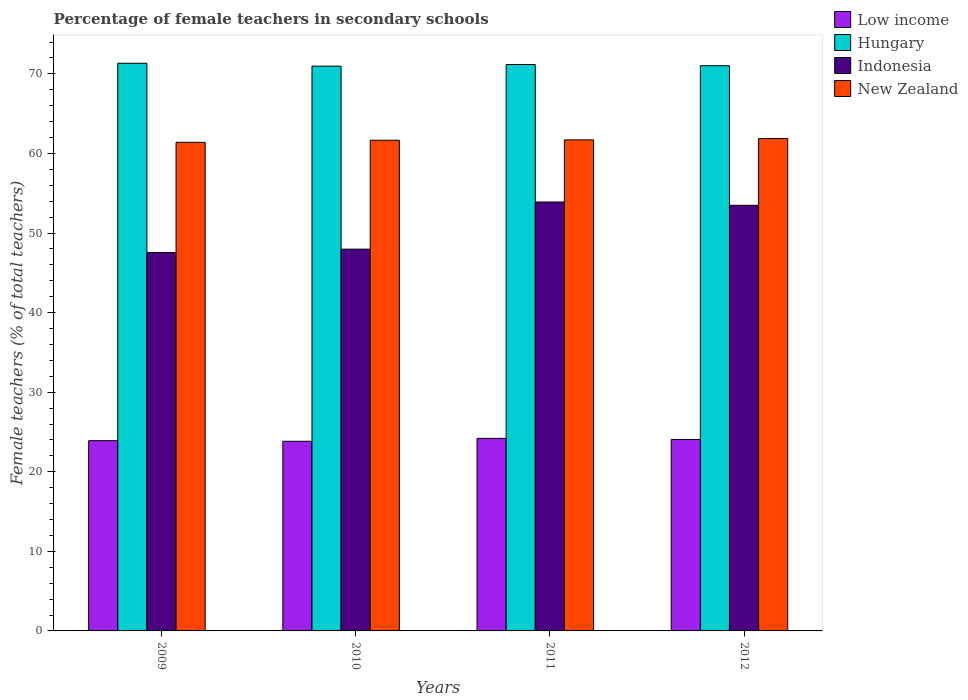How many different coloured bars are there?
Offer a very short reply. 4. Are the number of bars per tick equal to the number of legend labels?
Offer a terse response. Yes. What is the label of the 3rd group of bars from the left?
Keep it short and to the point. 2011. In how many cases, is the number of bars for a given year not equal to the number of legend labels?
Make the answer very short. 0. What is the percentage of female teachers in Indonesia in 2009?
Offer a terse response. 47.56. Across all years, what is the maximum percentage of female teachers in Low income?
Provide a succinct answer. 24.19. Across all years, what is the minimum percentage of female teachers in Indonesia?
Offer a terse response. 47.56. In which year was the percentage of female teachers in Low income minimum?
Make the answer very short. 2010. What is the total percentage of female teachers in Low income in the graph?
Provide a short and direct response. 95.99. What is the difference between the percentage of female teachers in New Zealand in 2009 and that in 2011?
Provide a short and direct response. -0.31. What is the difference between the percentage of female teachers in Hungary in 2010 and the percentage of female teachers in Indonesia in 2009?
Offer a very short reply. 23.41. What is the average percentage of female teachers in Indonesia per year?
Offer a terse response. 50.73. In the year 2011, what is the difference between the percentage of female teachers in Indonesia and percentage of female teachers in Low income?
Provide a succinct answer. 29.7. In how many years, is the percentage of female teachers in New Zealand greater than 28 %?
Your response must be concise. 4. What is the ratio of the percentage of female teachers in Hungary in 2009 to that in 2010?
Offer a very short reply. 1.01. Is the percentage of female teachers in Hungary in 2010 less than that in 2012?
Offer a terse response. Yes. Is the difference between the percentage of female teachers in Indonesia in 2009 and 2012 greater than the difference between the percentage of female teachers in Low income in 2009 and 2012?
Provide a short and direct response. No. What is the difference between the highest and the second highest percentage of female teachers in New Zealand?
Ensure brevity in your answer.  0.17. What is the difference between the highest and the lowest percentage of female teachers in Low income?
Your answer should be compact. 0.36. In how many years, is the percentage of female teachers in Low income greater than the average percentage of female teachers in Low income taken over all years?
Offer a terse response. 2. Is the sum of the percentage of female teachers in Hungary in 2009 and 2012 greater than the maximum percentage of female teachers in Low income across all years?
Offer a very short reply. Yes. Is it the case that in every year, the sum of the percentage of female teachers in New Zealand and percentage of female teachers in Indonesia is greater than the sum of percentage of female teachers in Low income and percentage of female teachers in Hungary?
Keep it short and to the point. Yes. What does the 1st bar from the left in 2012 represents?
Ensure brevity in your answer.  Low income. Is it the case that in every year, the sum of the percentage of female teachers in Hungary and percentage of female teachers in Low income is greater than the percentage of female teachers in Indonesia?
Make the answer very short. Yes. How many bars are there?
Offer a terse response. 16. How many years are there in the graph?
Offer a terse response. 4. Are the values on the major ticks of Y-axis written in scientific E-notation?
Provide a succinct answer. No. Does the graph contain grids?
Your answer should be very brief. No. Where does the legend appear in the graph?
Provide a short and direct response. Top right. What is the title of the graph?
Your answer should be very brief. Percentage of female teachers in secondary schools. Does "Equatorial Guinea" appear as one of the legend labels in the graph?
Provide a short and direct response. No. What is the label or title of the X-axis?
Keep it short and to the point. Years. What is the label or title of the Y-axis?
Make the answer very short. Female teachers (% of total teachers). What is the Female teachers (% of total teachers) in Low income in 2009?
Your answer should be very brief. 23.91. What is the Female teachers (% of total teachers) in Hungary in 2009?
Provide a succinct answer. 71.33. What is the Female teachers (% of total teachers) of Indonesia in 2009?
Provide a short and direct response. 47.56. What is the Female teachers (% of total teachers) in New Zealand in 2009?
Your answer should be compact. 61.4. What is the Female teachers (% of total teachers) of Low income in 2010?
Ensure brevity in your answer.  23.83. What is the Female teachers (% of total teachers) of Hungary in 2010?
Your response must be concise. 70.97. What is the Female teachers (% of total teachers) in Indonesia in 2010?
Offer a terse response. 47.97. What is the Female teachers (% of total teachers) in New Zealand in 2010?
Ensure brevity in your answer.  61.66. What is the Female teachers (% of total teachers) in Low income in 2011?
Your answer should be very brief. 24.19. What is the Female teachers (% of total teachers) in Hungary in 2011?
Offer a very short reply. 71.18. What is the Female teachers (% of total teachers) in Indonesia in 2011?
Your response must be concise. 53.9. What is the Female teachers (% of total teachers) in New Zealand in 2011?
Your answer should be compact. 61.71. What is the Female teachers (% of total teachers) in Low income in 2012?
Make the answer very short. 24.06. What is the Female teachers (% of total teachers) in Hungary in 2012?
Make the answer very short. 71.02. What is the Female teachers (% of total teachers) in Indonesia in 2012?
Your answer should be compact. 53.48. What is the Female teachers (% of total teachers) of New Zealand in 2012?
Your answer should be very brief. 61.88. Across all years, what is the maximum Female teachers (% of total teachers) of Low income?
Offer a very short reply. 24.19. Across all years, what is the maximum Female teachers (% of total teachers) of Hungary?
Keep it short and to the point. 71.33. Across all years, what is the maximum Female teachers (% of total teachers) in Indonesia?
Your response must be concise. 53.9. Across all years, what is the maximum Female teachers (% of total teachers) in New Zealand?
Keep it short and to the point. 61.88. Across all years, what is the minimum Female teachers (% of total teachers) in Low income?
Offer a terse response. 23.83. Across all years, what is the minimum Female teachers (% of total teachers) of Hungary?
Ensure brevity in your answer.  70.97. Across all years, what is the minimum Female teachers (% of total teachers) in Indonesia?
Offer a terse response. 47.56. Across all years, what is the minimum Female teachers (% of total teachers) of New Zealand?
Your answer should be compact. 61.4. What is the total Female teachers (% of total teachers) of Low income in the graph?
Offer a very short reply. 95.99. What is the total Female teachers (% of total teachers) in Hungary in the graph?
Provide a succinct answer. 284.5. What is the total Female teachers (% of total teachers) of Indonesia in the graph?
Your answer should be compact. 202.91. What is the total Female teachers (% of total teachers) of New Zealand in the graph?
Provide a succinct answer. 246.64. What is the difference between the Female teachers (% of total teachers) of Low income in 2009 and that in 2010?
Your answer should be compact. 0.08. What is the difference between the Female teachers (% of total teachers) in Hungary in 2009 and that in 2010?
Provide a succinct answer. 0.36. What is the difference between the Female teachers (% of total teachers) in Indonesia in 2009 and that in 2010?
Offer a terse response. -0.41. What is the difference between the Female teachers (% of total teachers) of New Zealand in 2009 and that in 2010?
Give a very brief answer. -0.26. What is the difference between the Female teachers (% of total teachers) of Low income in 2009 and that in 2011?
Make the answer very short. -0.29. What is the difference between the Female teachers (% of total teachers) of Hungary in 2009 and that in 2011?
Your answer should be compact. 0.15. What is the difference between the Female teachers (% of total teachers) of Indonesia in 2009 and that in 2011?
Ensure brevity in your answer.  -6.34. What is the difference between the Female teachers (% of total teachers) of New Zealand in 2009 and that in 2011?
Make the answer very short. -0.31. What is the difference between the Female teachers (% of total teachers) of Low income in 2009 and that in 2012?
Ensure brevity in your answer.  -0.16. What is the difference between the Female teachers (% of total teachers) in Hungary in 2009 and that in 2012?
Offer a terse response. 0.31. What is the difference between the Female teachers (% of total teachers) of Indonesia in 2009 and that in 2012?
Offer a terse response. -5.92. What is the difference between the Female teachers (% of total teachers) in New Zealand in 2009 and that in 2012?
Your answer should be compact. -0.48. What is the difference between the Female teachers (% of total teachers) in Low income in 2010 and that in 2011?
Offer a terse response. -0.36. What is the difference between the Female teachers (% of total teachers) in Hungary in 2010 and that in 2011?
Your answer should be compact. -0.21. What is the difference between the Female teachers (% of total teachers) of Indonesia in 2010 and that in 2011?
Give a very brief answer. -5.93. What is the difference between the Female teachers (% of total teachers) in New Zealand in 2010 and that in 2011?
Your response must be concise. -0.05. What is the difference between the Female teachers (% of total teachers) in Low income in 2010 and that in 2012?
Offer a terse response. -0.23. What is the difference between the Female teachers (% of total teachers) of Hungary in 2010 and that in 2012?
Make the answer very short. -0.06. What is the difference between the Female teachers (% of total teachers) of Indonesia in 2010 and that in 2012?
Keep it short and to the point. -5.51. What is the difference between the Female teachers (% of total teachers) in New Zealand in 2010 and that in 2012?
Make the answer very short. -0.22. What is the difference between the Female teachers (% of total teachers) in Low income in 2011 and that in 2012?
Your answer should be compact. 0.13. What is the difference between the Female teachers (% of total teachers) of Hungary in 2011 and that in 2012?
Your answer should be compact. 0.15. What is the difference between the Female teachers (% of total teachers) of Indonesia in 2011 and that in 2012?
Ensure brevity in your answer.  0.42. What is the difference between the Female teachers (% of total teachers) of New Zealand in 2011 and that in 2012?
Provide a short and direct response. -0.17. What is the difference between the Female teachers (% of total teachers) in Low income in 2009 and the Female teachers (% of total teachers) in Hungary in 2010?
Provide a succinct answer. -47.06. What is the difference between the Female teachers (% of total teachers) of Low income in 2009 and the Female teachers (% of total teachers) of Indonesia in 2010?
Offer a terse response. -24.06. What is the difference between the Female teachers (% of total teachers) of Low income in 2009 and the Female teachers (% of total teachers) of New Zealand in 2010?
Your answer should be very brief. -37.75. What is the difference between the Female teachers (% of total teachers) of Hungary in 2009 and the Female teachers (% of total teachers) of Indonesia in 2010?
Provide a short and direct response. 23.36. What is the difference between the Female teachers (% of total teachers) of Hungary in 2009 and the Female teachers (% of total teachers) of New Zealand in 2010?
Ensure brevity in your answer.  9.67. What is the difference between the Female teachers (% of total teachers) of Indonesia in 2009 and the Female teachers (% of total teachers) of New Zealand in 2010?
Provide a succinct answer. -14.1. What is the difference between the Female teachers (% of total teachers) in Low income in 2009 and the Female teachers (% of total teachers) in Hungary in 2011?
Give a very brief answer. -47.27. What is the difference between the Female teachers (% of total teachers) of Low income in 2009 and the Female teachers (% of total teachers) of Indonesia in 2011?
Your response must be concise. -29.99. What is the difference between the Female teachers (% of total teachers) of Low income in 2009 and the Female teachers (% of total teachers) of New Zealand in 2011?
Provide a succinct answer. -37.8. What is the difference between the Female teachers (% of total teachers) of Hungary in 2009 and the Female teachers (% of total teachers) of Indonesia in 2011?
Provide a succinct answer. 17.43. What is the difference between the Female teachers (% of total teachers) in Hungary in 2009 and the Female teachers (% of total teachers) in New Zealand in 2011?
Provide a short and direct response. 9.63. What is the difference between the Female teachers (% of total teachers) of Indonesia in 2009 and the Female teachers (% of total teachers) of New Zealand in 2011?
Give a very brief answer. -14.15. What is the difference between the Female teachers (% of total teachers) of Low income in 2009 and the Female teachers (% of total teachers) of Hungary in 2012?
Offer a terse response. -47.12. What is the difference between the Female teachers (% of total teachers) in Low income in 2009 and the Female teachers (% of total teachers) in Indonesia in 2012?
Provide a succinct answer. -29.57. What is the difference between the Female teachers (% of total teachers) in Low income in 2009 and the Female teachers (% of total teachers) in New Zealand in 2012?
Provide a succinct answer. -37.97. What is the difference between the Female teachers (% of total teachers) in Hungary in 2009 and the Female teachers (% of total teachers) in Indonesia in 2012?
Ensure brevity in your answer.  17.85. What is the difference between the Female teachers (% of total teachers) in Hungary in 2009 and the Female teachers (% of total teachers) in New Zealand in 2012?
Offer a very short reply. 9.46. What is the difference between the Female teachers (% of total teachers) in Indonesia in 2009 and the Female teachers (% of total teachers) in New Zealand in 2012?
Provide a short and direct response. -14.32. What is the difference between the Female teachers (% of total teachers) of Low income in 2010 and the Female teachers (% of total teachers) of Hungary in 2011?
Provide a succinct answer. -47.34. What is the difference between the Female teachers (% of total teachers) of Low income in 2010 and the Female teachers (% of total teachers) of Indonesia in 2011?
Your response must be concise. -30.07. What is the difference between the Female teachers (% of total teachers) in Low income in 2010 and the Female teachers (% of total teachers) in New Zealand in 2011?
Offer a very short reply. -37.87. What is the difference between the Female teachers (% of total teachers) in Hungary in 2010 and the Female teachers (% of total teachers) in Indonesia in 2011?
Offer a terse response. 17.07. What is the difference between the Female teachers (% of total teachers) of Hungary in 2010 and the Female teachers (% of total teachers) of New Zealand in 2011?
Ensure brevity in your answer.  9.26. What is the difference between the Female teachers (% of total teachers) in Indonesia in 2010 and the Female teachers (% of total teachers) in New Zealand in 2011?
Give a very brief answer. -13.73. What is the difference between the Female teachers (% of total teachers) of Low income in 2010 and the Female teachers (% of total teachers) of Hungary in 2012?
Provide a succinct answer. -47.19. What is the difference between the Female teachers (% of total teachers) of Low income in 2010 and the Female teachers (% of total teachers) of Indonesia in 2012?
Your response must be concise. -29.65. What is the difference between the Female teachers (% of total teachers) in Low income in 2010 and the Female teachers (% of total teachers) in New Zealand in 2012?
Provide a short and direct response. -38.04. What is the difference between the Female teachers (% of total teachers) in Hungary in 2010 and the Female teachers (% of total teachers) in Indonesia in 2012?
Offer a terse response. 17.49. What is the difference between the Female teachers (% of total teachers) of Hungary in 2010 and the Female teachers (% of total teachers) of New Zealand in 2012?
Make the answer very short. 9.09. What is the difference between the Female teachers (% of total teachers) in Indonesia in 2010 and the Female teachers (% of total teachers) in New Zealand in 2012?
Offer a terse response. -13.9. What is the difference between the Female teachers (% of total teachers) of Low income in 2011 and the Female teachers (% of total teachers) of Hungary in 2012?
Provide a short and direct response. -46.83. What is the difference between the Female teachers (% of total teachers) in Low income in 2011 and the Female teachers (% of total teachers) in Indonesia in 2012?
Your answer should be very brief. -29.29. What is the difference between the Female teachers (% of total teachers) of Low income in 2011 and the Female teachers (% of total teachers) of New Zealand in 2012?
Your answer should be compact. -37.68. What is the difference between the Female teachers (% of total teachers) in Hungary in 2011 and the Female teachers (% of total teachers) in Indonesia in 2012?
Keep it short and to the point. 17.69. What is the difference between the Female teachers (% of total teachers) in Hungary in 2011 and the Female teachers (% of total teachers) in New Zealand in 2012?
Offer a very short reply. 9.3. What is the difference between the Female teachers (% of total teachers) in Indonesia in 2011 and the Female teachers (% of total teachers) in New Zealand in 2012?
Your response must be concise. -7.98. What is the average Female teachers (% of total teachers) of Low income per year?
Ensure brevity in your answer.  24. What is the average Female teachers (% of total teachers) of Hungary per year?
Offer a terse response. 71.12. What is the average Female teachers (% of total teachers) in Indonesia per year?
Offer a terse response. 50.73. What is the average Female teachers (% of total teachers) in New Zealand per year?
Provide a short and direct response. 61.66. In the year 2009, what is the difference between the Female teachers (% of total teachers) of Low income and Female teachers (% of total teachers) of Hungary?
Provide a succinct answer. -47.42. In the year 2009, what is the difference between the Female teachers (% of total teachers) of Low income and Female teachers (% of total teachers) of Indonesia?
Provide a short and direct response. -23.65. In the year 2009, what is the difference between the Female teachers (% of total teachers) in Low income and Female teachers (% of total teachers) in New Zealand?
Give a very brief answer. -37.49. In the year 2009, what is the difference between the Female teachers (% of total teachers) in Hungary and Female teachers (% of total teachers) in Indonesia?
Offer a terse response. 23.77. In the year 2009, what is the difference between the Female teachers (% of total teachers) of Hungary and Female teachers (% of total teachers) of New Zealand?
Your response must be concise. 9.93. In the year 2009, what is the difference between the Female teachers (% of total teachers) in Indonesia and Female teachers (% of total teachers) in New Zealand?
Your response must be concise. -13.84. In the year 2010, what is the difference between the Female teachers (% of total teachers) in Low income and Female teachers (% of total teachers) in Hungary?
Ensure brevity in your answer.  -47.14. In the year 2010, what is the difference between the Female teachers (% of total teachers) of Low income and Female teachers (% of total teachers) of Indonesia?
Give a very brief answer. -24.14. In the year 2010, what is the difference between the Female teachers (% of total teachers) in Low income and Female teachers (% of total teachers) in New Zealand?
Make the answer very short. -37.83. In the year 2010, what is the difference between the Female teachers (% of total teachers) in Hungary and Female teachers (% of total teachers) in Indonesia?
Your answer should be compact. 23. In the year 2010, what is the difference between the Female teachers (% of total teachers) of Hungary and Female teachers (% of total teachers) of New Zealand?
Provide a succinct answer. 9.31. In the year 2010, what is the difference between the Female teachers (% of total teachers) of Indonesia and Female teachers (% of total teachers) of New Zealand?
Provide a succinct answer. -13.69. In the year 2011, what is the difference between the Female teachers (% of total teachers) of Low income and Female teachers (% of total teachers) of Hungary?
Offer a terse response. -46.98. In the year 2011, what is the difference between the Female teachers (% of total teachers) in Low income and Female teachers (% of total teachers) in Indonesia?
Provide a succinct answer. -29.7. In the year 2011, what is the difference between the Female teachers (% of total teachers) of Low income and Female teachers (% of total teachers) of New Zealand?
Provide a short and direct response. -37.51. In the year 2011, what is the difference between the Female teachers (% of total teachers) in Hungary and Female teachers (% of total teachers) in Indonesia?
Keep it short and to the point. 17.28. In the year 2011, what is the difference between the Female teachers (% of total teachers) in Hungary and Female teachers (% of total teachers) in New Zealand?
Your answer should be very brief. 9.47. In the year 2011, what is the difference between the Female teachers (% of total teachers) of Indonesia and Female teachers (% of total teachers) of New Zealand?
Your answer should be very brief. -7.81. In the year 2012, what is the difference between the Female teachers (% of total teachers) in Low income and Female teachers (% of total teachers) in Hungary?
Make the answer very short. -46.96. In the year 2012, what is the difference between the Female teachers (% of total teachers) of Low income and Female teachers (% of total teachers) of Indonesia?
Your response must be concise. -29.42. In the year 2012, what is the difference between the Female teachers (% of total teachers) of Low income and Female teachers (% of total teachers) of New Zealand?
Offer a terse response. -37.81. In the year 2012, what is the difference between the Female teachers (% of total teachers) of Hungary and Female teachers (% of total teachers) of Indonesia?
Ensure brevity in your answer.  17.54. In the year 2012, what is the difference between the Female teachers (% of total teachers) in Hungary and Female teachers (% of total teachers) in New Zealand?
Offer a terse response. 9.15. In the year 2012, what is the difference between the Female teachers (% of total teachers) of Indonesia and Female teachers (% of total teachers) of New Zealand?
Your answer should be very brief. -8.39. What is the ratio of the Female teachers (% of total teachers) of Hungary in 2009 to that in 2010?
Provide a succinct answer. 1.01. What is the ratio of the Female teachers (% of total teachers) of Low income in 2009 to that in 2011?
Your answer should be compact. 0.99. What is the ratio of the Female teachers (% of total teachers) of Indonesia in 2009 to that in 2011?
Offer a very short reply. 0.88. What is the ratio of the Female teachers (% of total teachers) of Hungary in 2009 to that in 2012?
Give a very brief answer. 1. What is the ratio of the Female teachers (% of total teachers) of Indonesia in 2009 to that in 2012?
Keep it short and to the point. 0.89. What is the ratio of the Female teachers (% of total teachers) in New Zealand in 2009 to that in 2012?
Offer a terse response. 0.99. What is the ratio of the Female teachers (% of total teachers) of Indonesia in 2010 to that in 2011?
Make the answer very short. 0.89. What is the ratio of the Female teachers (% of total teachers) in Hungary in 2010 to that in 2012?
Provide a succinct answer. 1. What is the ratio of the Female teachers (% of total teachers) of Indonesia in 2010 to that in 2012?
Your answer should be very brief. 0.9. What is the ratio of the Female teachers (% of total teachers) in New Zealand in 2010 to that in 2012?
Offer a very short reply. 1. What is the ratio of the Female teachers (% of total teachers) of Low income in 2011 to that in 2012?
Your response must be concise. 1.01. What is the ratio of the Female teachers (% of total teachers) of Hungary in 2011 to that in 2012?
Give a very brief answer. 1. What is the ratio of the Female teachers (% of total teachers) of New Zealand in 2011 to that in 2012?
Make the answer very short. 1. What is the difference between the highest and the second highest Female teachers (% of total teachers) of Low income?
Keep it short and to the point. 0.13. What is the difference between the highest and the second highest Female teachers (% of total teachers) of Hungary?
Your answer should be compact. 0.15. What is the difference between the highest and the second highest Female teachers (% of total teachers) of Indonesia?
Make the answer very short. 0.42. What is the difference between the highest and the second highest Female teachers (% of total teachers) of New Zealand?
Your answer should be compact. 0.17. What is the difference between the highest and the lowest Female teachers (% of total teachers) in Low income?
Your answer should be compact. 0.36. What is the difference between the highest and the lowest Female teachers (% of total teachers) in Hungary?
Your answer should be very brief. 0.36. What is the difference between the highest and the lowest Female teachers (% of total teachers) of Indonesia?
Offer a terse response. 6.34. What is the difference between the highest and the lowest Female teachers (% of total teachers) of New Zealand?
Your answer should be compact. 0.48. 